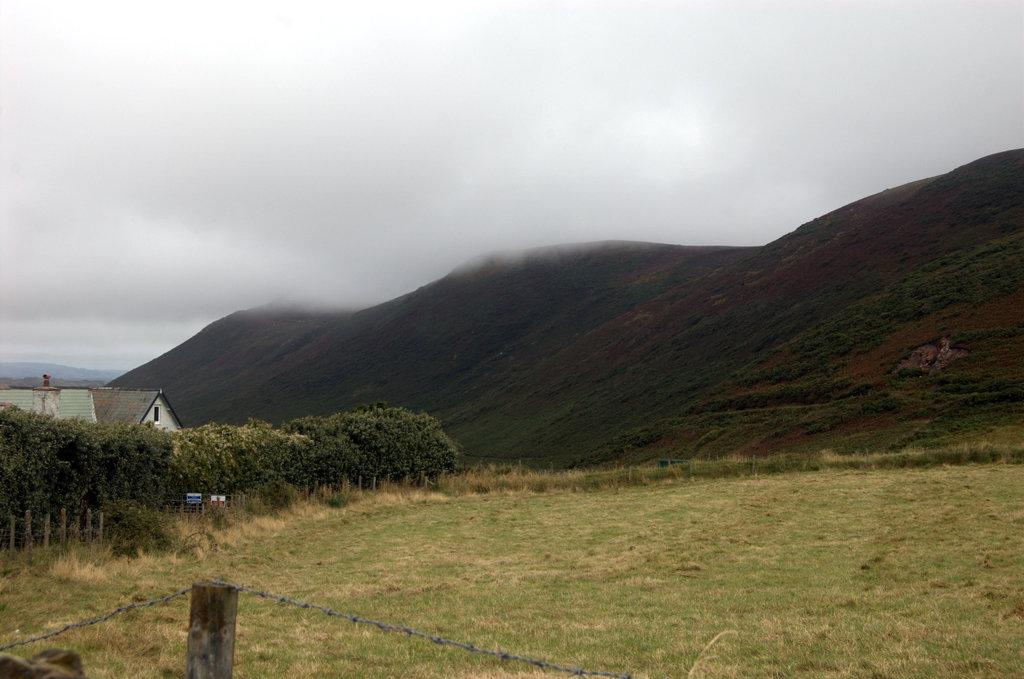What type of vegetation can be seen in the image? There are trees, plants, and grass visible in the image. What structures are present in the image? There are poles, boards, houses, and fencing wire at the bottom of the image. What type of terrain is visible in the image? There are hills in the image. What is the weather like in the image? There is fog in the image, which suggests a cool or damp environment. What part of the natural environment is visible in the image? The sky is visible in the background of the image. What type of soap is being used to clean the plants in the image? There is no soap or cleaning activity involving plants present in the image. What season is depicted in the image? The provided facts do not indicate a specific season, so it cannot be determined from the image. 